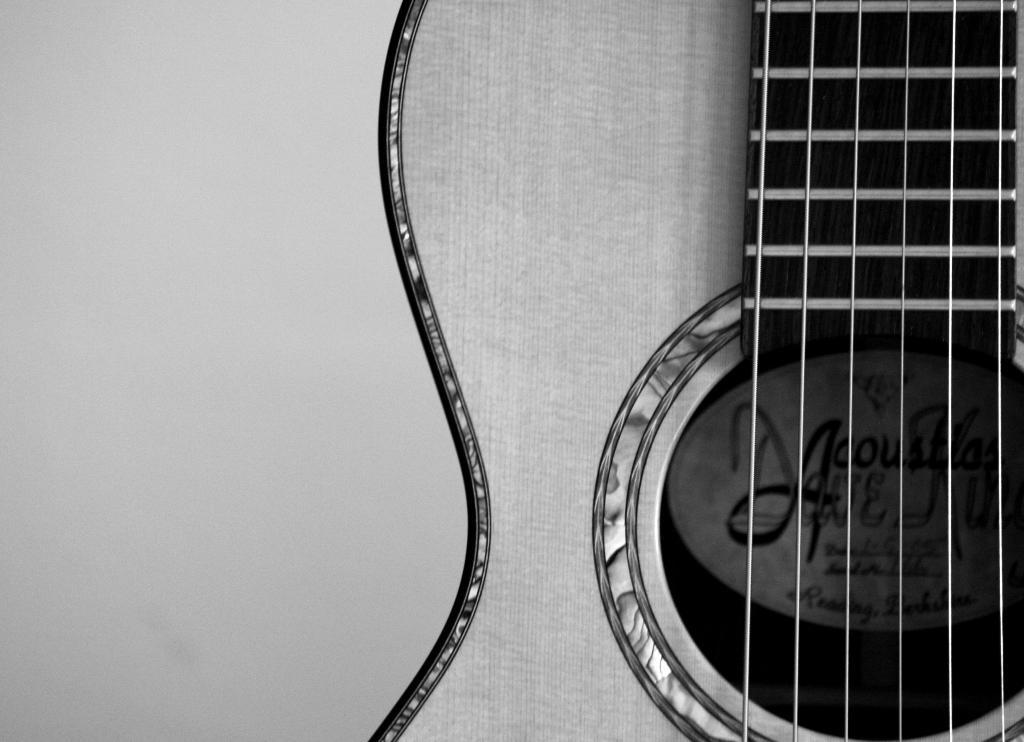What musical instrument is present in the image? There is a guitar in the image. What type of strings does the guitar have? The guitar has six strings. What is the guitar made of? The guitar is made of wood. What part of the guitar is typically used to play chords? The fretboard is the part of the guitar typically used to play chords. What type of metal can be seen at the end of the guitar in the image? There is no metal visible at the end of the guitar in the image. The guitar is made of wood, and the end of the guitar is not shown in the image. 